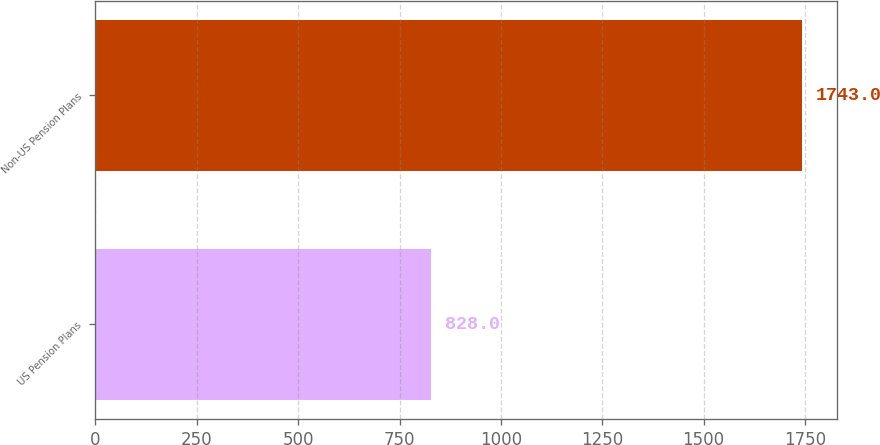<chart> <loc_0><loc_0><loc_500><loc_500><bar_chart><fcel>US Pension Plans<fcel>Non-US Pension Plans<nl><fcel>828<fcel>1743<nl></chart> 